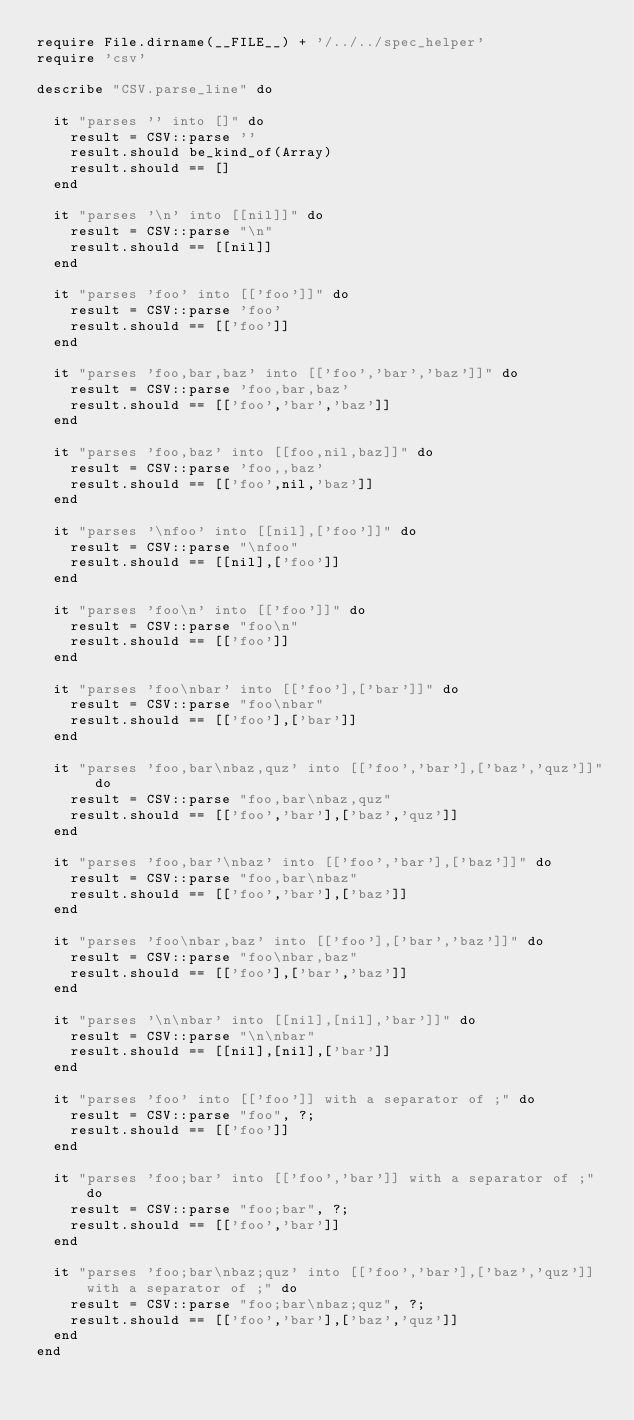Convert code to text. <code><loc_0><loc_0><loc_500><loc_500><_Ruby_>require File.dirname(__FILE__) + '/../../spec_helper'
require 'csv'

describe "CSV.parse_line" do
  
  it "parses '' into []" do
    result = CSV::parse ''
    result.should be_kind_of(Array)
    result.should == []
  end

  it "parses '\n' into [[nil]]" do
    result = CSV::parse "\n"
    result.should == [[nil]]
  end
 
  it "parses 'foo' into [['foo']]" do
    result = CSV::parse 'foo'
    result.should == [['foo']]
  end

  it "parses 'foo,bar,baz' into [['foo','bar','baz']]" do
    result = CSV::parse 'foo,bar,baz'
    result.should == [['foo','bar','baz']]
  end

  it "parses 'foo,baz' into [[foo,nil,baz]]" do
    result = CSV::parse 'foo,,baz'
    result.should == [['foo',nil,'baz']]
  end

  it "parses '\nfoo' into [[nil],['foo']]" do
    result = CSV::parse "\nfoo"
    result.should == [[nil],['foo']]
  end

  it "parses 'foo\n' into [['foo']]" do
    result = CSV::parse "foo\n"
    result.should == [['foo']]
  end

  it "parses 'foo\nbar' into [['foo'],['bar']]" do 
    result = CSV::parse "foo\nbar"
    result.should == [['foo'],['bar']]
  end

  it "parses 'foo,bar\nbaz,quz' into [['foo','bar'],['baz','quz']]" do
    result = CSV::parse "foo,bar\nbaz,quz"
    result.should == [['foo','bar'],['baz','quz']]
  end

  it "parses 'foo,bar'\nbaz' into [['foo','bar'],['baz']]" do
    result = CSV::parse "foo,bar\nbaz"
    result.should == [['foo','bar'],['baz']]
  end

  it "parses 'foo\nbar,baz' into [['foo'],['bar','baz']]" do
    result = CSV::parse "foo\nbar,baz"
    result.should == [['foo'],['bar','baz']]
  end

  it "parses '\n\nbar' into [[nil],[nil],'bar']]" do
    result = CSV::parse "\n\nbar"
    result.should == [[nil],[nil],['bar']]
  end

  it "parses 'foo' into [['foo']] with a separator of ;" do
    result = CSV::parse "foo", ?;
    result.should == [['foo']]
  end

  it "parses 'foo;bar' into [['foo','bar']] with a separator of ;" do
    result = CSV::parse "foo;bar", ?;
    result.should == [['foo','bar']]
  end

  it "parses 'foo;bar\nbaz;quz' into [['foo','bar'],['baz','quz']] with a separator of ;" do
    result = CSV::parse "foo;bar\nbaz;quz", ?;
    result.should == [['foo','bar'],['baz','quz']]
  end
end
</code> 